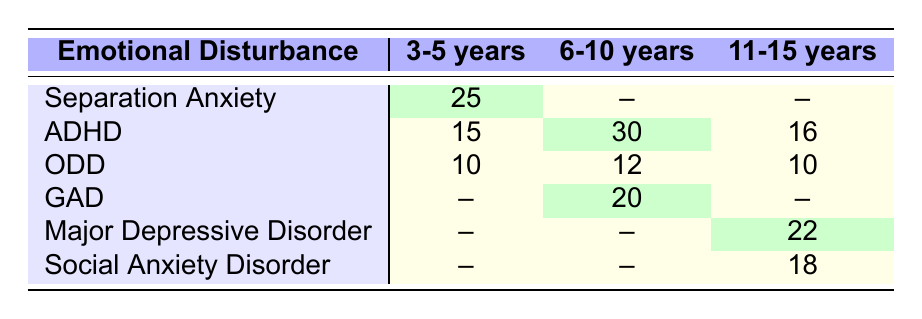What is the frequency of Separation Anxiety in the 3-5 years age group? In the table, under the "3-5 years" column, the row "Separation Anxiety" indicates a frequency of 25.
Answer: 25 How many cases of ADHD are reported in the 6-10 years age group? Looking at the "6-10 years" column under the "ADHD" row, the frequency is 30.
Answer: 30 Is there any emotional disturbance recorded for the 3-5 years age group related to Major Depressive Disorder? In the table, there is no mention of "Major Depressive Disorder" under the "3-5 years" age group, so the answer is no.
Answer: No What is the total number of cases of Oppositional Defiant Disorder (ODD) across all age groups? To find the total, we add the frequencies for ODD: 10 (3-5 years) + 12 (6-10 years) + 10 (11-15 years) = 32.
Answer: 32 Which age group has the highest frequency of emotional disturbances reported? By comparing the highest values in each age group: 25 in 3-5 years, 30 in 6-10 years, and 22 in 11-15 years, the highest frequency is 30, which is in the 6-10 years age group.
Answer: 6-10 years What is the difference in frequency of ADHD between the 6-10 years and 11-15 years age groups? The frequency for ADHD in 6-10 years is 30 and in 11-15 years is 16. The difference is 30 - 16 = 14.
Answer: 14 Is Attention Deficit Hyperactivity Disorder (ADHD) the only disturbance recorded in the 3-5 years age group? In the "3-5 years" age group, there are three disturbances: Separation Anxiety, ADHD, and ODD, which means the answer is no.
Answer: No What is the average frequency of emotional disturbances for the 11-15 years age group? The frequencies for this age group are: Major Depressive Disorder (22), Social Anxiety Disorder (18), ADHD (16), and ODD (10). Summing these gives 22 + 18 + 16 + 10 = 66. There are 4 disturbances, so the average is 66 / 4 = 16.5.
Answer: 16.5 In which age group is Generalized Anxiety Disorder (GAD) reported? The table shows that GAD appears under the "6-10 years" age group.
Answer: 6-10 years 